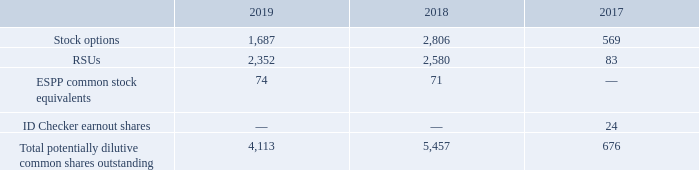Net Income (Loss) Per Share
The Company calculates net income (loss) per share in accordance with FASB ASC Topic 260,Earnings per Share. Basic net income (loss) per share is based on the weighted-average number of common shares outstanding during the period. Diluted net income (loss) per share also gives effect to all potentially dilutive securities outstanding during the period, such as restricted stock units (“RSUs”), stock options, and Employee Stock Purchase Plan ("ESPP") shares, if dilutive. In a period with a net loss position, potentially dilutive securities are not included in the computation of diluted net loss because to do so would be antidilutive, and the number of shares used to calculate basic and diluted net loss is the same.
For the fiscal years ended September 30, 2019, 2018 and 2017, the following potentially dilutive common shares were excluded from the net income (loss)
per share calculation, as they would have been antidilutive (amounts in thousands):
How does the company calculate net income (loss) per share? In accordance with fasb asc topic 260,earnings per share. What is basic net income (loss) per share based on? The weighted-average number of common shares outstanding during the period. What is the amount of potentially dilutive common shares outstanding of stock options and RSUs in 2019, respectively?
Answer scale should be: thousand. 1,687, 2,352. What is the percentage change in the amount of potentially dilutive common shares outstanding of ESPP common stock equivalents from 2018 to 2019?
Answer scale should be: percent. (74-71)/71 
Answer: 4.23. What is the average of total potentially dilutive common shares outstanding from 2017 to 2019?
Answer scale should be: thousand. (4,113+5,457+676)/3 
Answer: 3415.33. What is the ratio of the amount of stock options between 2018 to 2019? 2,806/1,687 
Answer: 1.66. 